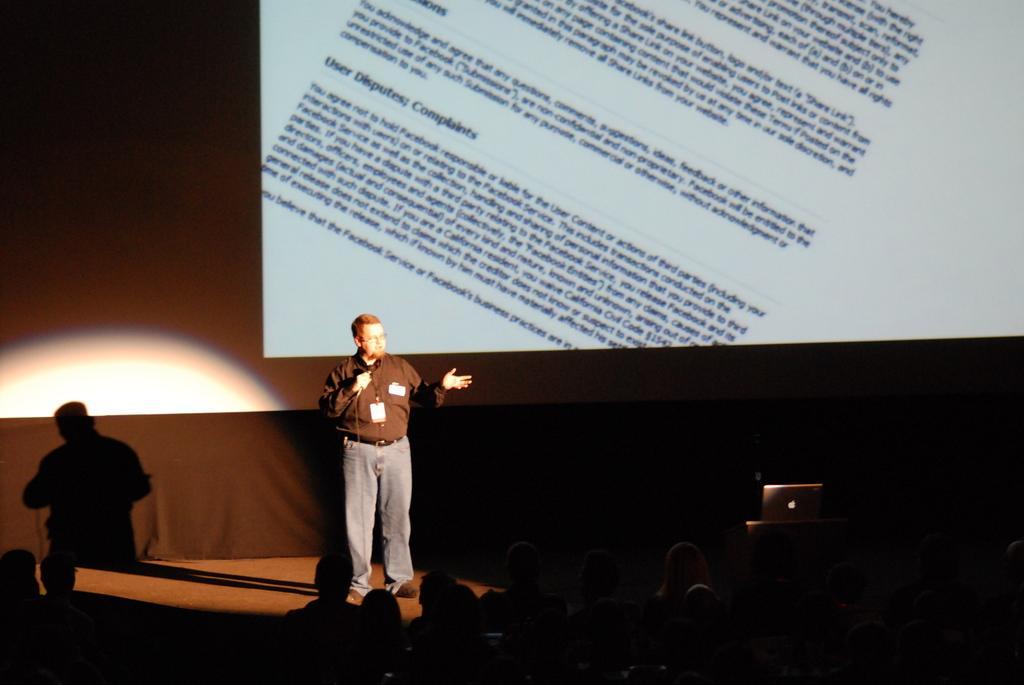How would you summarize this image in a sentence or two? In this image we can see one man with spectacles, wearing an ID card, holding a microphone with wire, standing on the stage and talking. There are some people in front of the stage, one laptop on the table on the stage, one curtain in the background on the left side of the image, on projector screen with text in the background, we can see the shadow of a man and light on the left side of the image. The image is dark. 